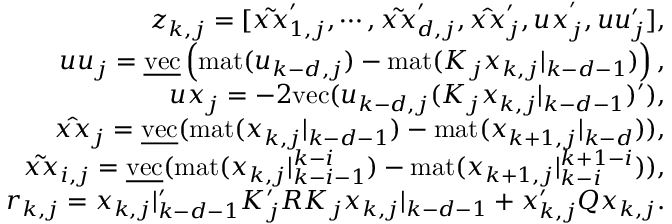Convert formula to latex. <formula><loc_0><loc_0><loc_500><loc_500>\begin{array} { r l r } & { z _ { k , j } = [ \tilde { x x } _ { 1 , j } ^ { \prime } , \cdots , \tilde { x x } _ { d , j } ^ { \prime } , \hat { x x } _ { j } ^ { \prime } , u x _ { j } ^ { ^ { \prime } } , u u _ { j } ^ { \prime } ] , } \\ & { u u _ { j } = \underline { v e c } \left ( m a t ( u _ { k - d , j } ) - m a t ( K _ { j } x _ { k , j } | _ { k - d - 1 } ) \right ) , } \\ & { u x _ { j } = - 2 v e c ( u _ { k - d , j } ( K _ { j } x _ { k , j } | _ { k - d - 1 } ) ^ { \prime } ) , } \\ & { \hat { x x } _ { j } = \underline { v e c } ( m a t ( x _ { k , j } | _ { k - d - 1 } ) - m a t ( x _ { k + 1 , j } | _ { k - d } ) ) , } \\ & { \tilde { x x } _ { i , j } = \underline { v e c } ( m a t ( x _ { k , j } | _ { k - i - 1 } ^ { k - i } ) - m a t ( x _ { k + 1 , j } | _ { k - i } ^ { k + 1 - i } ) ) , } \\ & { r _ { k , j } = x _ { k , j } | _ { k - d - 1 } ^ { \prime } K _ { j } ^ { \prime } R K _ { j } x _ { k , j } | _ { k - d - 1 } + x _ { k , j } ^ { \prime } Q x _ { k , j } . } \end{array}</formula> 